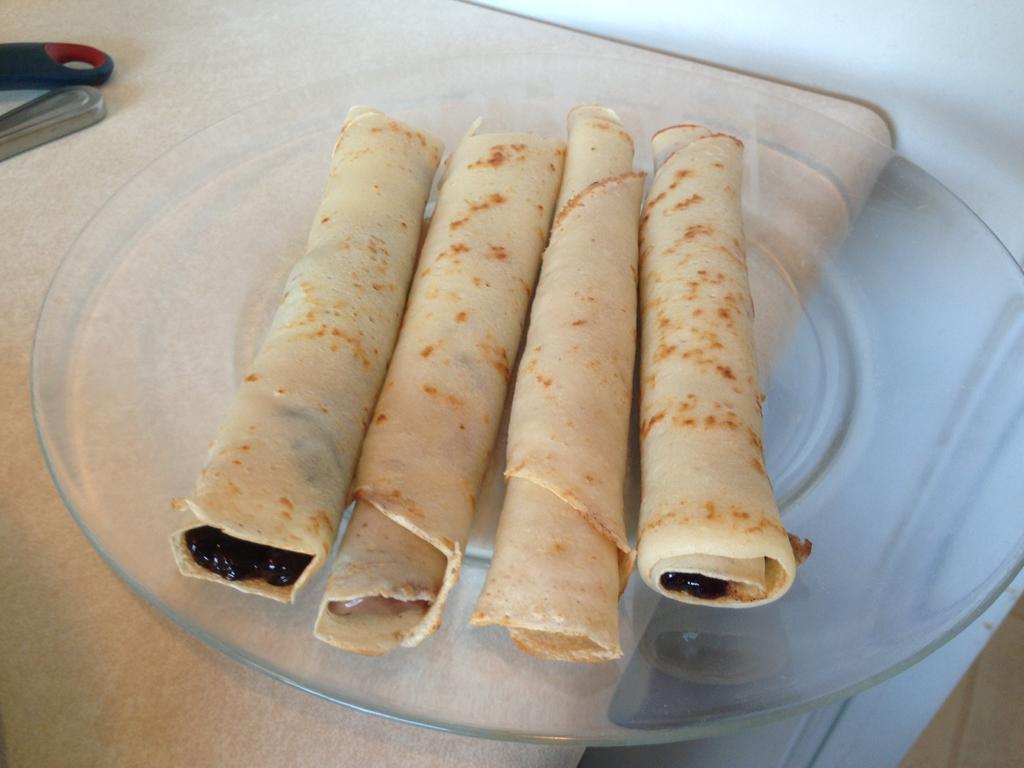Describe this image in one or two sentences. In this image we can see a plate on a surface. On the plate there are four rolls. 